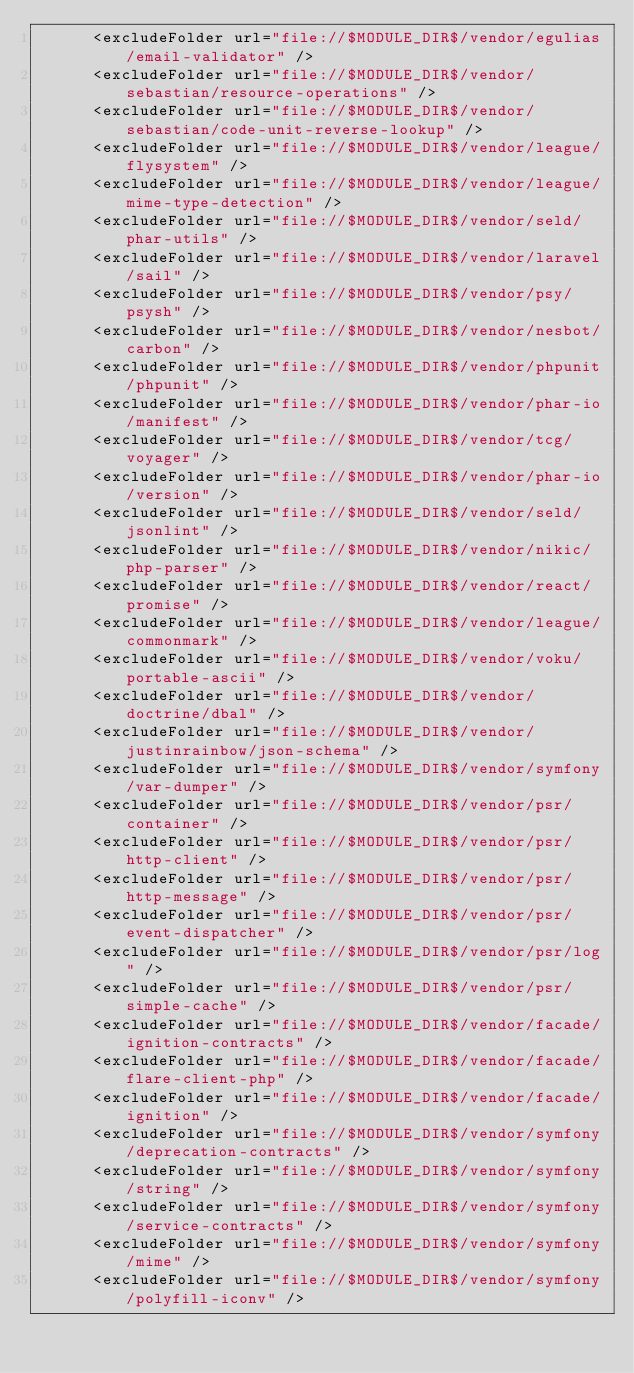<code> <loc_0><loc_0><loc_500><loc_500><_XML_>      <excludeFolder url="file://$MODULE_DIR$/vendor/egulias/email-validator" />
      <excludeFolder url="file://$MODULE_DIR$/vendor/sebastian/resource-operations" />
      <excludeFolder url="file://$MODULE_DIR$/vendor/sebastian/code-unit-reverse-lookup" />
      <excludeFolder url="file://$MODULE_DIR$/vendor/league/flysystem" />
      <excludeFolder url="file://$MODULE_DIR$/vendor/league/mime-type-detection" />
      <excludeFolder url="file://$MODULE_DIR$/vendor/seld/phar-utils" />
      <excludeFolder url="file://$MODULE_DIR$/vendor/laravel/sail" />
      <excludeFolder url="file://$MODULE_DIR$/vendor/psy/psysh" />
      <excludeFolder url="file://$MODULE_DIR$/vendor/nesbot/carbon" />
      <excludeFolder url="file://$MODULE_DIR$/vendor/phpunit/phpunit" />
      <excludeFolder url="file://$MODULE_DIR$/vendor/phar-io/manifest" />
      <excludeFolder url="file://$MODULE_DIR$/vendor/tcg/voyager" />
      <excludeFolder url="file://$MODULE_DIR$/vendor/phar-io/version" />
      <excludeFolder url="file://$MODULE_DIR$/vendor/seld/jsonlint" />
      <excludeFolder url="file://$MODULE_DIR$/vendor/nikic/php-parser" />
      <excludeFolder url="file://$MODULE_DIR$/vendor/react/promise" />
      <excludeFolder url="file://$MODULE_DIR$/vendor/league/commonmark" />
      <excludeFolder url="file://$MODULE_DIR$/vendor/voku/portable-ascii" />
      <excludeFolder url="file://$MODULE_DIR$/vendor/doctrine/dbal" />
      <excludeFolder url="file://$MODULE_DIR$/vendor/justinrainbow/json-schema" />
      <excludeFolder url="file://$MODULE_DIR$/vendor/symfony/var-dumper" />
      <excludeFolder url="file://$MODULE_DIR$/vendor/psr/container" />
      <excludeFolder url="file://$MODULE_DIR$/vendor/psr/http-client" />
      <excludeFolder url="file://$MODULE_DIR$/vendor/psr/http-message" />
      <excludeFolder url="file://$MODULE_DIR$/vendor/psr/event-dispatcher" />
      <excludeFolder url="file://$MODULE_DIR$/vendor/psr/log" />
      <excludeFolder url="file://$MODULE_DIR$/vendor/psr/simple-cache" />
      <excludeFolder url="file://$MODULE_DIR$/vendor/facade/ignition-contracts" />
      <excludeFolder url="file://$MODULE_DIR$/vendor/facade/flare-client-php" />
      <excludeFolder url="file://$MODULE_DIR$/vendor/facade/ignition" />
      <excludeFolder url="file://$MODULE_DIR$/vendor/symfony/deprecation-contracts" />
      <excludeFolder url="file://$MODULE_DIR$/vendor/symfony/string" />
      <excludeFolder url="file://$MODULE_DIR$/vendor/symfony/service-contracts" />
      <excludeFolder url="file://$MODULE_DIR$/vendor/symfony/mime" />
      <excludeFolder url="file://$MODULE_DIR$/vendor/symfony/polyfill-iconv" /></code> 